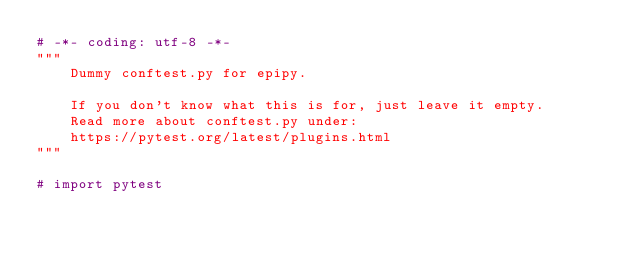Convert code to text. <code><loc_0><loc_0><loc_500><loc_500><_Python_># -*- coding: utf-8 -*-
"""
    Dummy conftest.py for epipy.

    If you don't know what this is for, just leave it empty.
    Read more about conftest.py under:
    https://pytest.org/latest/plugins.html
"""

# import pytest
</code> 